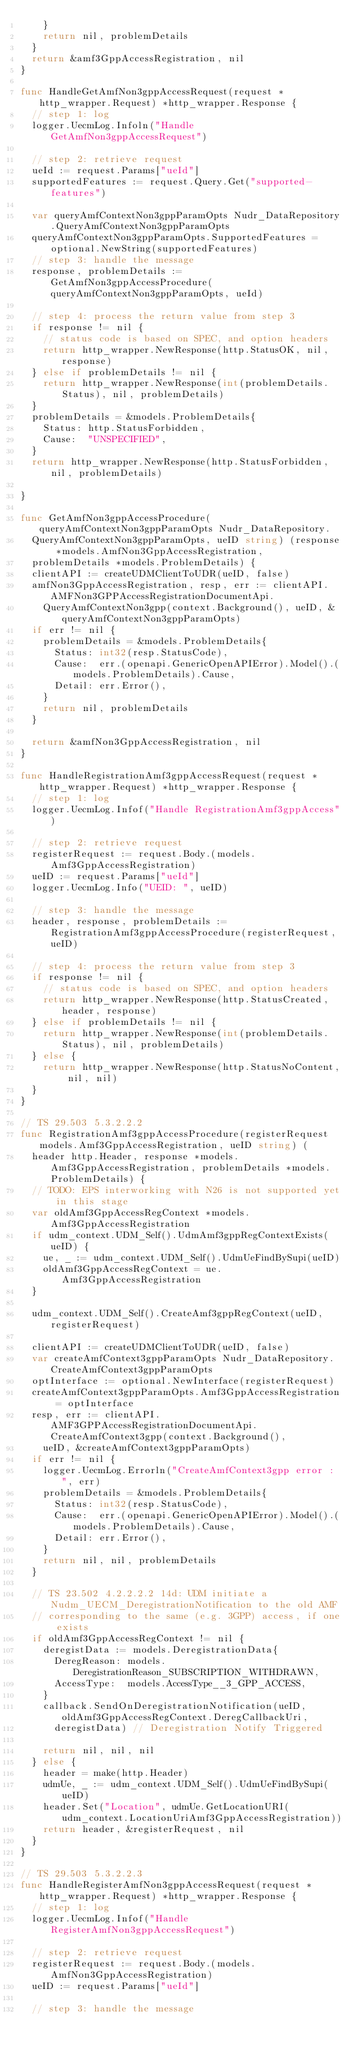<code> <loc_0><loc_0><loc_500><loc_500><_Go_>		}
		return nil, problemDetails
	}
	return &amf3GppAccessRegistration, nil
}

func HandleGetAmfNon3gppAccessRequest(request *http_wrapper.Request) *http_wrapper.Response {
	// step 1: log
	logger.UecmLog.Infoln("Handle GetAmfNon3gppAccessRequest")

	// step 2: retrieve request
	ueId := request.Params["ueId"]
	supportedFeatures := request.Query.Get("supported-features")

	var queryAmfContextNon3gppParamOpts Nudr_DataRepository.QueryAmfContextNon3gppParamOpts
	queryAmfContextNon3gppParamOpts.SupportedFeatures = optional.NewString(supportedFeatures)
	// step 3: handle the message
	response, problemDetails := GetAmfNon3gppAccessProcedure(queryAmfContextNon3gppParamOpts, ueId)

	// step 4: process the return value from step 3
	if response != nil {
		// status code is based on SPEC, and option headers
		return http_wrapper.NewResponse(http.StatusOK, nil, response)
	} else if problemDetails != nil {
		return http_wrapper.NewResponse(int(problemDetails.Status), nil, problemDetails)
	}
	problemDetails = &models.ProblemDetails{
		Status: http.StatusForbidden,
		Cause:  "UNSPECIFIED",
	}
	return http_wrapper.NewResponse(http.StatusForbidden, nil, problemDetails)

}

func GetAmfNon3gppAccessProcedure(queryAmfContextNon3gppParamOpts Nudr_DataRepository.
	QueryAmfContextNon3gppParamOpts, ueID string) (response *models.AmfNon3GppAccessRegistration,
	problemDetails *models.ProblemDetails) {
	clientAPI := createUDMClientToUDR(ueID, false)
	amfNon3GppAccessRegistration, resp, err := clientAPI.AMFNon3GPPAccessRegistrationDocumentApi.
		QueryAmfContextNon3gpp(context.Background(), ueID, &queryAmfContextNon3gppParamOpts)
	if err != nil {
		problemDetails = &models.ProblemDetails{
			Status: int32(resp.StatusCode),
			Cause:  err.(openapi.GenericOpenAPIError).Model().(models.ProblemDetails).Cause,
			Detail: err.Error(),
		}
		return nil, problemDetails
	}

	return &amfNon3GppAccessRegistration, nil
}

func HandleRegistrationAmf3gppAccessRequest(request *http_wrapper.Request) *http_wrapper.Response {
	// step 1: log
	logger.UecmLog.Infof("Handle RegistrationAmf3gppAccess")

	// step 2: retrieve request
	registerRequest := request.Body.(models.Amf3GppAccessRegistration)
	ueID := request.Params["ueId"]
	logger.UecmLog.Info("UEID: ", ueID)

	// step 3: handle the message
	header, response, problemDetails := RegistrationAmf3gppAccessProcedure(registerRequest, ueID)

	// step 4: process the return value from step 3
	if response != nil {
		// status code is based on SPEC, and option headers
		return http_wrapper.NewResponse(http.StatusCreated, header, response)
	} else if problemDetails != nil {
		return http_wrapper.NewResponse(int(problemDetails.Status), nil, problemDetails)
	} else {
		return http_wrapper.NewResponse(http.StatusNoContent, nil, nil)
	}
}

// TS 29.503 5.3.2.2.2
func RegistrationAmf3gppAccessProcedure(registerRequest models.Amf3GppAccessRegistration, ueID string) (
	header http.Header, response *models.Amf3GppAccessRegistration, problemDetails *models.ProblemDetails) {
	// TODO: EPS interworking with N26 is not supported yet in this stage
	var oldAmf3GppAccessRegContext *models.Amf3GppAccessRegistration
	if udm_context.UDM_Self().UdmAmf3gppRegContextExists(ueID) {
		ue, _ := udm_context.UDM_Self().UdmUeFindBySupi(ueID)
		oldAmf3GppAccessRegContext = ue.Amf3GppAccessRegistration
	}

	udm_context.UDM_Self().CreateAmf3gppRegContext(ueID, registerRequest)

	clientAPI := createUDMClientToUDR(ueID, false)
	var createAmfContext3gppParamOpts Nudr_DataRepository.CreateAmfContext3gppParamOpts
	optInterface := optional.NewInterface(registerRequest)
	createAmfContext3gppParamOpts.Amf3GppAccessRegistration = optInterface
	resp, err := clientAPI.AMF3GPPAccessRegistrationDocumentApi.CreateAmfContext3gpp(context.Background(),
		ueID, &createAmfContext3gppParamOpts)
	if err != nil {
		logger.UecmLog.Errorln("CreateAmfContext3gpp error : ", err)
		problemDetails = &models.ProblemDetails{
			Status: int32(resp.StatusCode),
			Cause:  err.(openapi.GenericOpenAPIError).Model().(models.ProblemDetails).Cause,
			Detail: err.Error(),
		}
		return nil, nil, problemDetails
	}

	// TS 23.502 4.2.2.2.2 14d: UDM initiate a Nudm_UECM_DeregistrationNotification to the old AMF
	// corresponding to the same (e.g. 3GPP) access, if one exists
	if oldAmf3GppAccessRegContext != nil {
		deregistData := models.DeregistrationData{
			DeregReason: models.DeregistrationReason_SUBSCRIPTION_WITHDRAWN,
			AccessType:  models.AccessType__3_GPP_ACCESS,
		}
		callback.SendOnDeregistrationNotification(ueID, oldAmf3GppAccessRegContext.DeregCallbackUri,
			deregistData) // Deregistration Notify Triggered

		return nil, nil, nil
	} else {
		header = make(http.Header)
		udmUe, _ := udm_context.UDM_Self().UdmUeFindBySupi(ueID)
		header.Set("Location", udmUe.GetLocationURI(udm_context.LocationUriAmf3GppAccessRegistration))
		return header, &registerRequest, nil
	}
}

// TS 29.503 5.3.2.2.3
func HandleRegisterAmfNon3gppAccessRequest(request *http_wrapper.Request) *http_wrapper.Response {
	// step 1: log
	logger.UecmLog.Infof("Handle RegisterAmfNon3gppAccessRequest")

	// step 2: retrieve request
	registerRequest := request.Body.(models.AmfNon3GppAccessRegistration)
	ueID := request.Params["ueId"]

	// step 3: handle the message</code> 